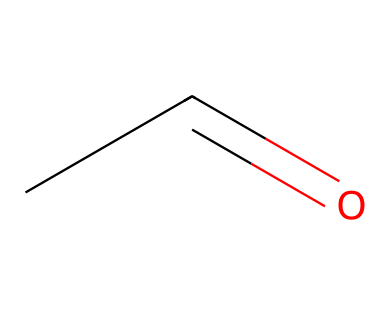What is the molecular formula of acetaldehyde? The molecular formula can be determined by counting the carbon (C), hydrogen (H), and oxygen (O) atoms represented in the structure. The SMILES CC=O indicates 2 carbons, 4 hydrogens, and 1 oxygen, resulting in the formula C2H4O.
Answer: C2H4O How many hydrogen atoms are in acetaldehyde? In the molecular structure shown by the SMILES CC=O, we can see that there are four hydrogen atoms attached to the two carbon atoms, resulting in a total of 4 hydrogen atoms.
Answer: 4 What type of functional group is present in acetaldehyde? The structure indicates that acetaldehyde contains a carbonyl group (C=O) bonded to a carbon, classifying it as an aldehyde due to the presence of the carbonyl group at the terminal position.
Answer: aldehyde What is the total number of atoms in acetaldehyde? By analyzing the molecular formula C2H4O, we can count the total atoms: 2 carbons + 4 hydrogens + 1 oxygen = 7 total atoms present in the molecule.
Answer: 7 Does acetaldehyde have a double bond? The SMILES CC=O indicates the presence of a double bond between one carbon and oxygen, confirming that this molecule contains a double bond.
Answer: yes What are the primary industrial uses of acetaldehyde? Acetaldehyde is primarily used in the production of acetic acid and various other chemicals, including perfumes and flavorings, due to its reactive properties.
Answer: production of acetic acid Is acetaldehyde a saturated or unsaturated compound? The presence of a carbonyl group (C=O) suggests that while the compound has single bonds, it also contains a double bond, indicating that it is unsaturated.
Answer: unsaturated 